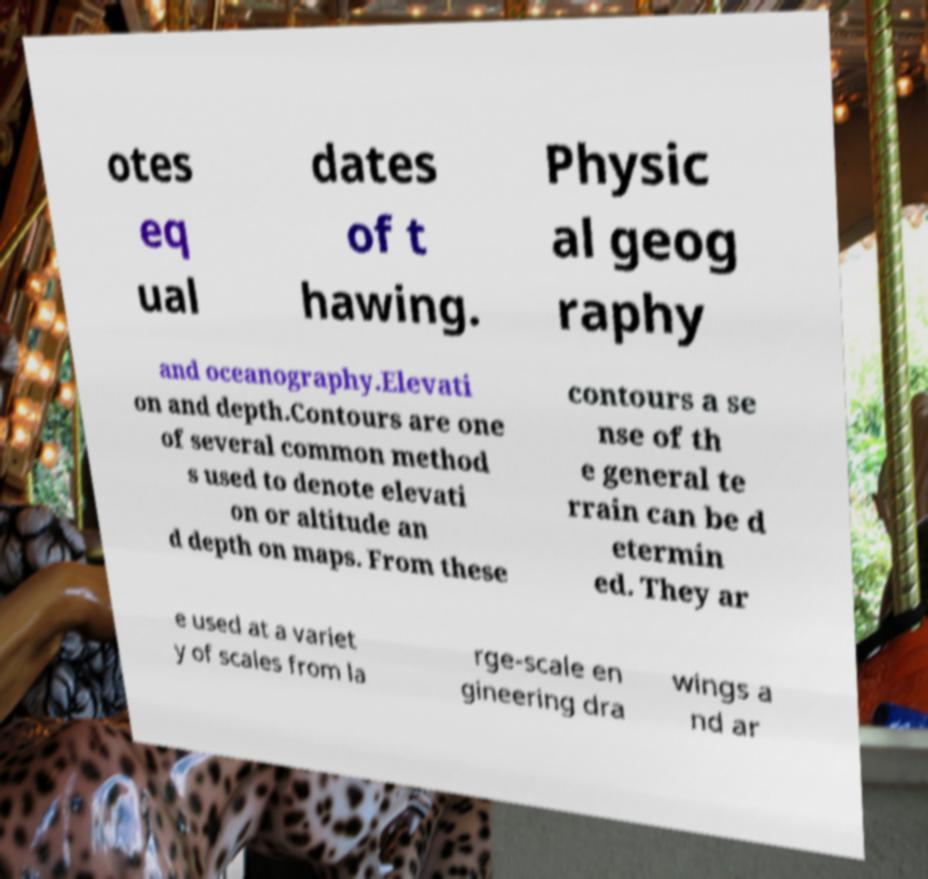Please identify and transcribe the text found in this image. otes eq ual dates of t hawing. Physic al geog raphy and oceanography.Elevati on and depth.Contours are one of several common method s used to denote elevati on or altitude an d depth on maps. From these contours a se nse of th e general te rrain can be d etermin ed. They ar e used at a variet y of scales from la rge-scale en gineering dra wings a nd ar 